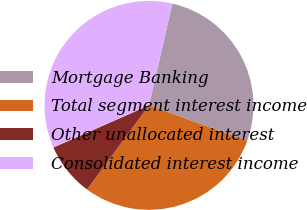Convert chart. <chart><loc_0><loc_0><loc_500><loc_500><pie_chart><fcel>Mortgage Banking<fcel>Total segment interest income<fcel>Other unallocated interest<fcel>Consolidated interest income<nl><fcel>26.91%<fcel>29.6%<fcel>8.29%<fcel>35.2%<nl></chart> 